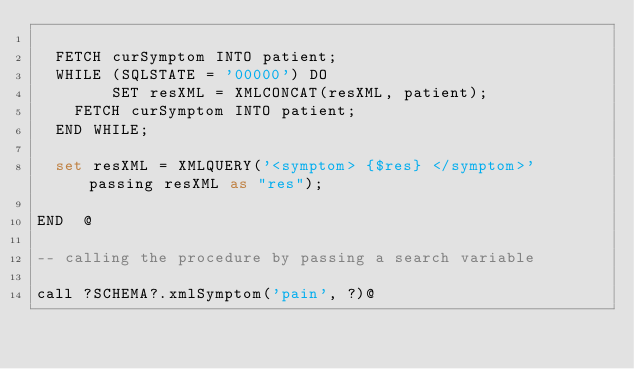Convert code to text. <code><loc_0><loc_0><loc_500><loc_500><_SQL_>
  FETCH curSymptom INTO patient;
  WHILE (SQLSTATE = '00000') DO
	    SET resXML = XMLCONCAT(resXML, patient);
    FETCH curSymptom INTO patient;
  END WHILE;

  set resXML = XMLQUERY('<symptom> {$res} </symptom>' passing resXML as "res");

END  @

-- calling the procedure by passing a search variable

call ?SCHEMA?.xmlSymptom('pain', ?)@</code> 